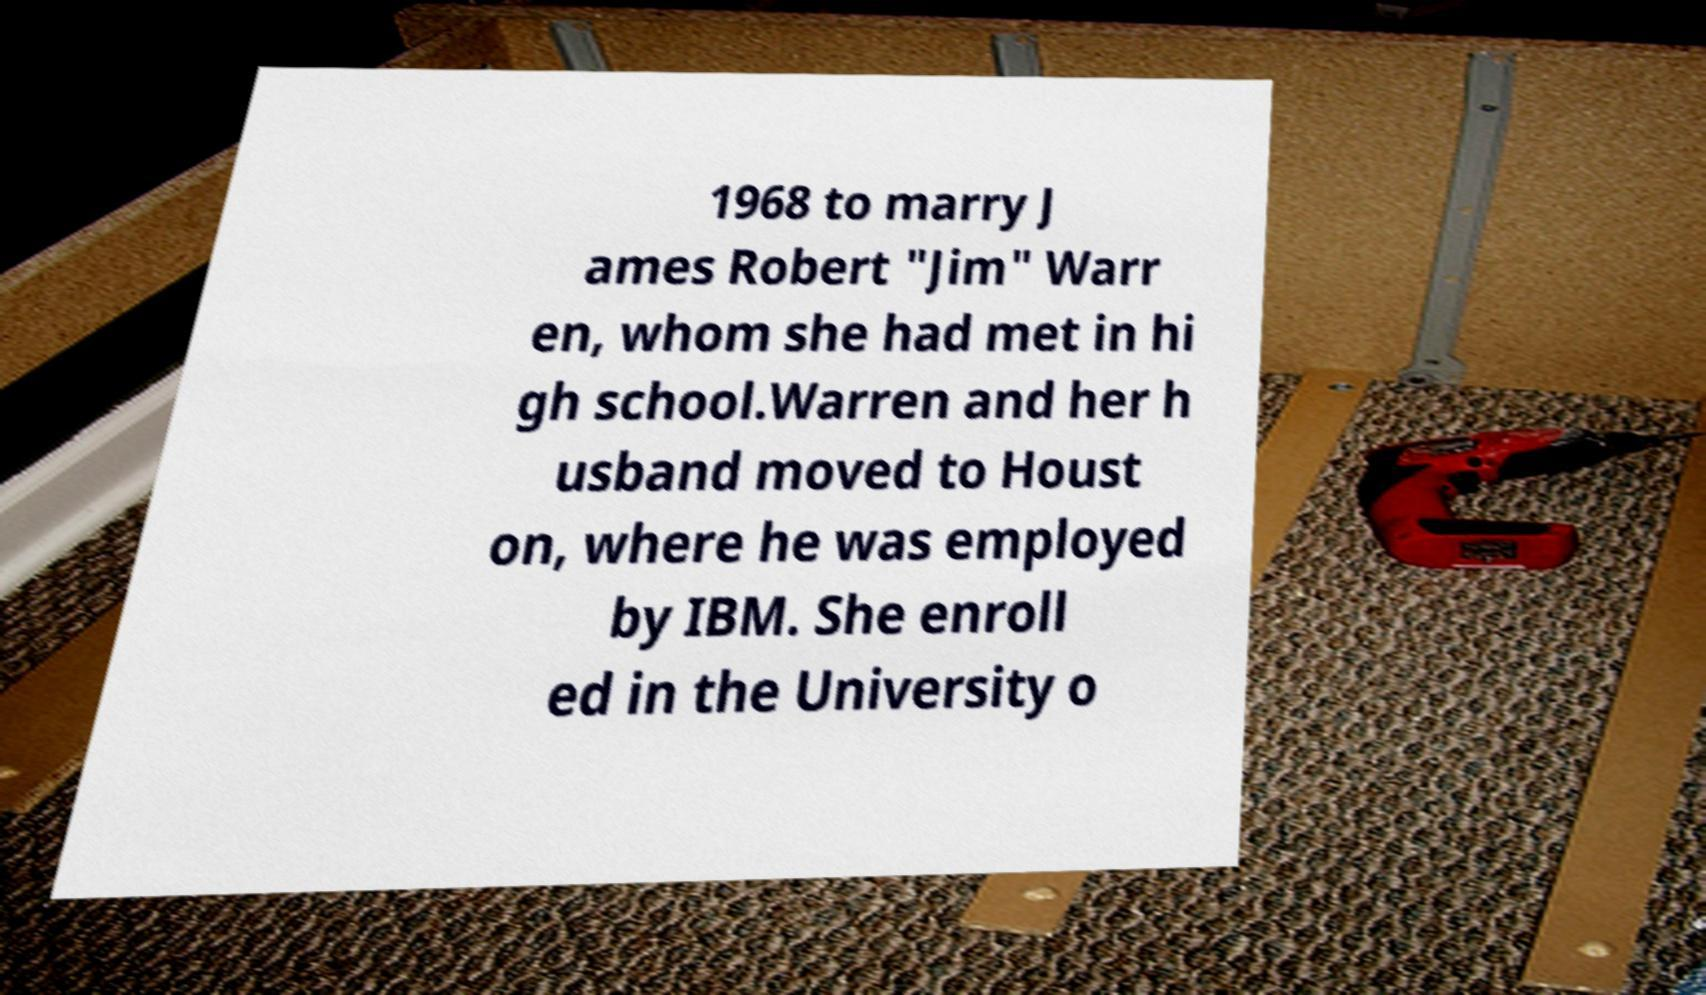For documentation purposes, I need the text within this image transcribed. Could you provide that? 1968 to marry J ames Robert "Jim" Warr en, whom she had met in hi gh school.Warren and her h usband moved to Houst on, where he was employed by IBM. She enroll ed in the University o 